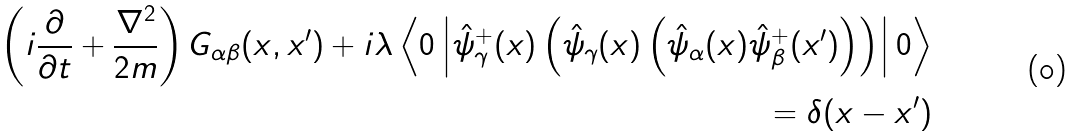<formula> <loc_0><loc_0><loc_500><loc_500>\left ( i \frac { \partial } { \partial t } + \frac { \nabla ^ { 2 } } { 2 m } \right ) G _ { \alpha \beta } ( x , x ^ { \prime } ) + i \lambda \left \langle 0 \left | \hat { \psi } ^ { + } _ { \gamma } ( x ) \left ( \hat { \psi } _ { \gamma } ( x ) \left ( \hat { \psi } _ { \alpha } ( x ) \hat { \psi } ^ { + } _ { \beta } ( x ^ { \prime } ) \right ) \right ) \right | 0 \right \rangle \\ = \delta ( x - x ^ { \prime } )</formula> 